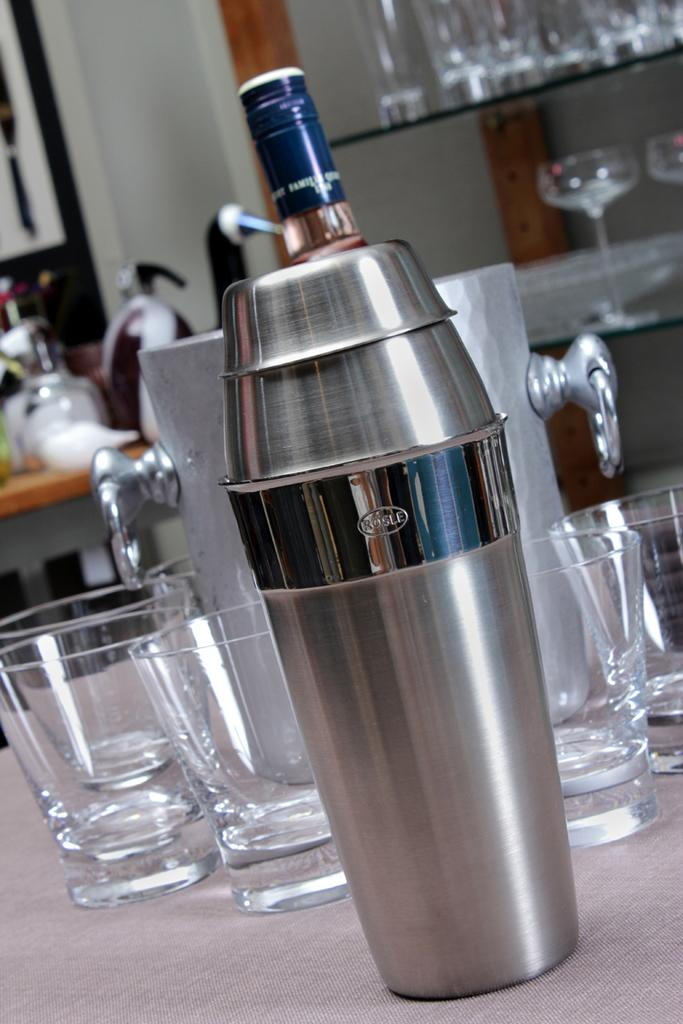<image>
Offer a succinct explanation of the picture presented. a Rosle cocktail mixer is in front of a wine cooler and glasses 